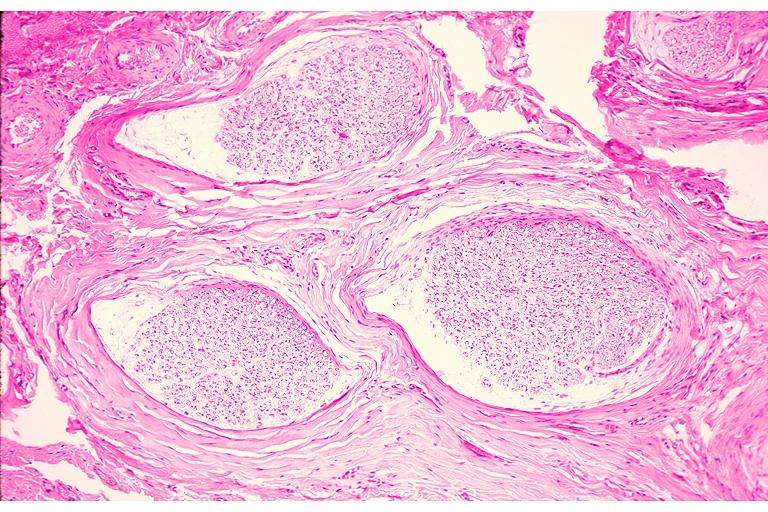what is present?
Answer the question using a single word or phrase. Oral 